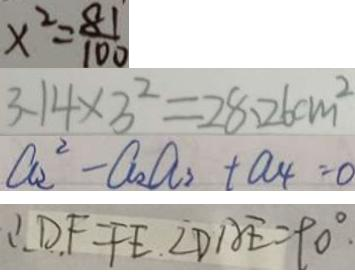Convert formula to latex. <formula><loc_0><loc_0><loc_500><loc_500>x ^ { 2 } = \frac { 8 1 } { 1 0 0 } 
 3 . 1 4 \times 3 ^ { 2 } = 2 8 . 2 6 c m ^ { 2 } 
 a _ { 2 } ^ { 2 } - a _ { 2 } a _ { 3 } + a _ { 4 } = 0 
 \therefore D F = F E . \angle D A E = 9 0 ^ { \circ } .</formula> 